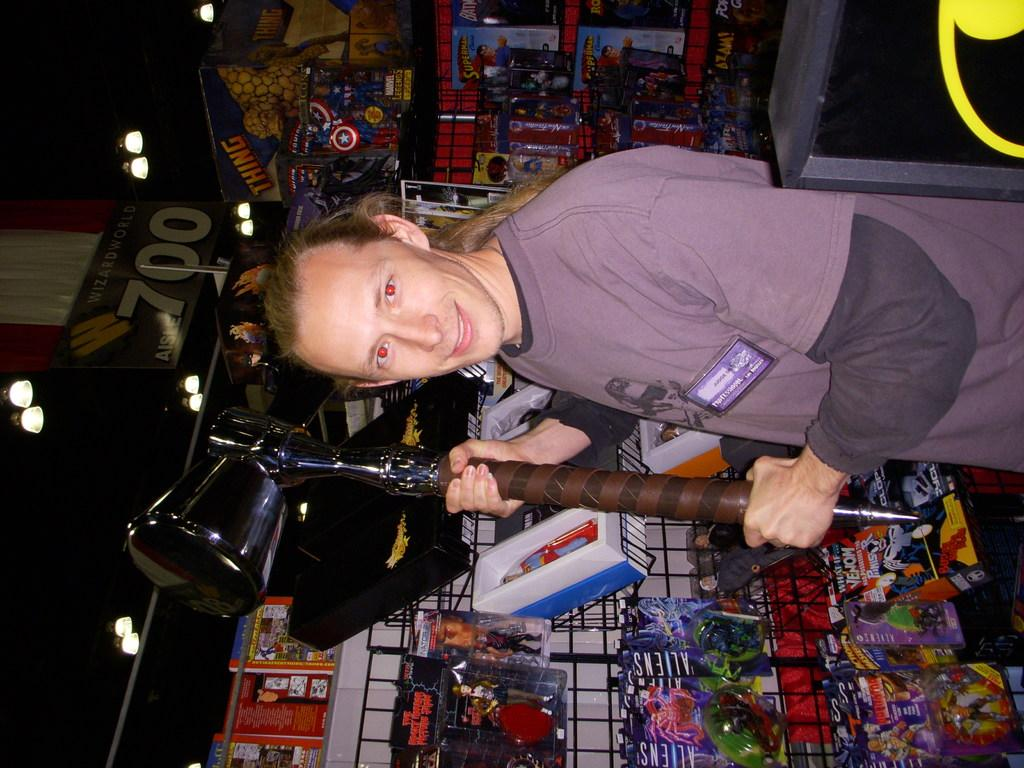What is the person in the image doing? The person is standing in the image. What is the person holding in the image? The person is holding an object. What can be seen in the background of the image? There are toys and things in a mesh stand in the background. What type of lighting is visible in the image? There are lights visible in the image. What is the board used for in the image? The board's purpose is not clear from the facts provided. What is the table used for in the image? The table's purpose is not clear from the facts provided. What type of animal is the person kissing in the image? There is no animal present in the image, and the person is not kissing anyone or anything. 